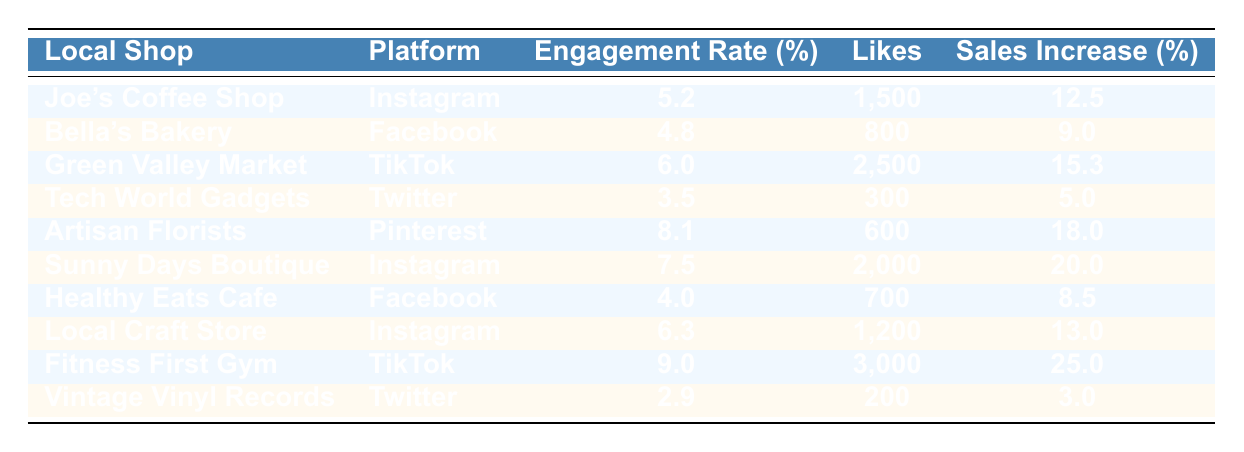What is the engagement rate of Joe's Coffee Shop on Instagram? The table lists Joe's Coffee Shop under Instagram with an engagement rate of 5.2%.
Answer: 5.2% Which local shop had the highest increase in sales? Upon reviewing the table, Fitness First Gym has the highest increase in sales at 25.0%.
Answer: Fitness First Gym What is the average increase in sales for the shops that posted on Instagram? The increase in sales for Instagram posts is 12.5% (Joe's Coffee Shop), 20.0% (Sunny Days Boutique), and 13.0% (Local Craft Store). The average is (12.5 + 20.0 + 13.0) / 3 = 15.2%.
Answer: 15.2% Was the engagement rate for Vintage Vinyl Records greater than 3.0%? Vintage Vinyl Records has an engagement rate of 2.9%, which is less than 3.0%. Therefore, the statement is false.
Answer: No How many total likes did the shops on Facebook receive? The shops on Facebook are Bella's Bakery with 800 likes and Healthy Eats Cafe with 700 likes. The total likes are 800 + 700 = 1500.
Answer: 1500 Which platform had the lowest engagement rate, and what is that rate? Looking at the table, Twitter has the lowest engagement rate at 2.9% for Vintage Vinyl Records.
Answer: Twitter, 2.9% If we categorize the shops by their increases in sales, how many shops had an increase greater than 15%? The shops with an increase greater than 15% are Green Valley Market (15.3%), Artisan Florists (18.0%), Sunny Days Boutique (20.0%), and Fitness First Gym (25.0%). That adds up to four shops.
Answer: 4 Which local shop had the most likes on TikTok? Green Valley Market and Fitness First Gym both used TikTok, receiving 2500 and 3000 likes, respectively. Fitness First Gym had the most likes at 3000.
Answer: Fitness First Gym What is the difference in engagement rate between the shop with the highest and lowest engagement rates? Fitness First Gym has the highest engagement rate at 9.0%, while Vintage Vinyl Records has the lowest at 2.9%. The difference is 9.0 - 2.9 = 6.1%.
Answer: 6.1% Did any shop achieve an increase in sales of over 10%? Yes, several shops achieved this: Joe's Coffee Shop (12.5%), Green Valley Market (15.3%), Artisan Florists (18.0%), Sunny Days Boutique (20.0%), Local Craft Store (13.0%), and Fitness First Gym (25.0%). Therefore, the answer is yes.
Answer: Yes 